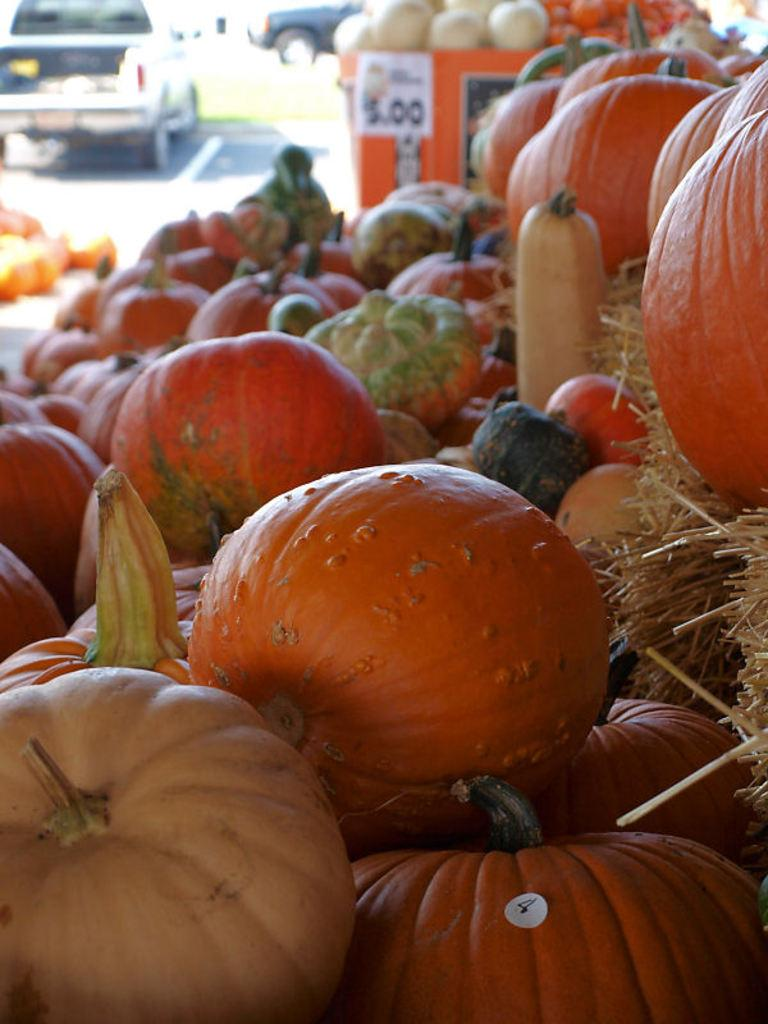What types of plants are in the foreground of the image? There are pumpkins and vegetables in the foreground of the image. What is the texture of the ground in the foreground? Dry grass is present in the foreground of the image. What can be seen in the background of the image? There are vehicles visible in the background of the image. What type of grain is being harvested in the image? There is no grain being harvested in the image; it features pumpkins, vegetables, and dry grass in the foreground. How many geese are visible in the image? There are no geese present in the image. 